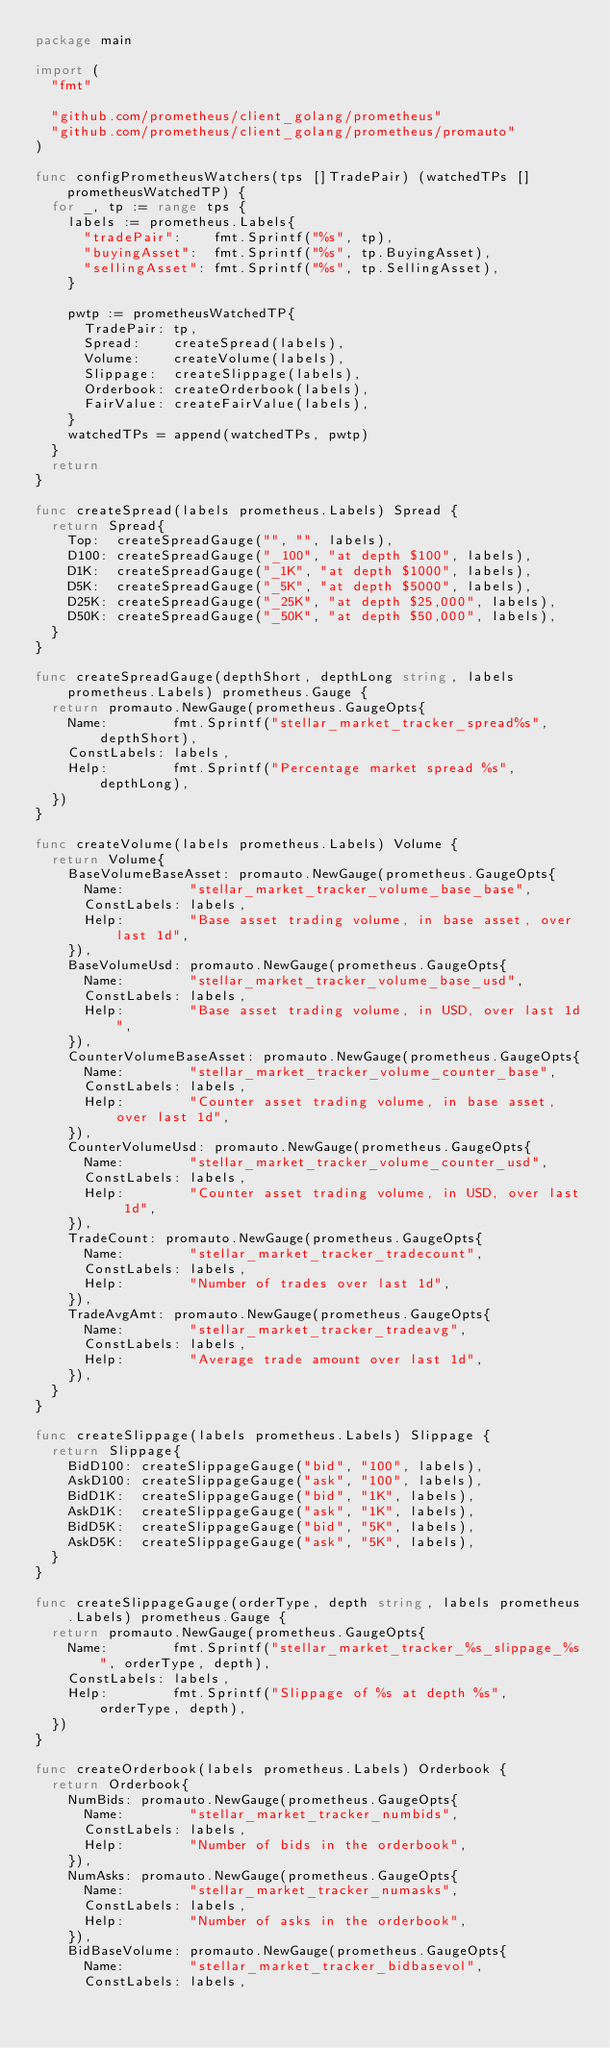<code> <loc_0><loc_0><loc_500><loc_500><_Go_>package main

import (
	"fmt"

	"github.com/prometheus/client_golang/prometheus"
	"github.com/prometheus/client_golang/prometheus/promauto"
)

func configPrometheusWatchers(tps []TradePair) (watchedTPs []prometheusWatchedTP) {
	for _, tp := range tps {
		labels := prometheus.Labels{
			"tradePair":    fmt.Sprintf("%s", tp),
			"buyingAsset":  fmt.Sprintf("%s", tp.BuyingAsset),
			"sellingAsset": fmt.Sprintf("%s", tp.SellingAsset),
		}

		pwtp := prometheusWatchedTP{
			TradePair: tp,
			Spread:    createSpread(labels),
			Volume:    createVolume(labels),
			Slippage:  createSlippage(labels),
			Orderbook: createOrderbook(labels),
			FairValue: createFairValue(labels),
		}
		watchedTPs = append(watchedTPs, pwtp)
	}
	return
}

func createSpread(labels prometheus.Labels) Spread {
	return Spread{
		Top:  createSpreadGauge("", "", labels),
		D100: createSpreadGauge("_100", "at depth $100", labels),
		D1K:  createSpreadGauge("_1K", "at depth $1000", labels),
		D5K:  createSpreadGauge("_5K", "at depth $5000", labels),
		D25K: createSpreadGauge("_25K", "at depth $25,000", labels),
		D50K: createSpreadGauge("_50K", "at depth $50,000", labels),
	}
}

func createSpreadGauge(depthShort, depthLong string, labels prometheus.Labels) prometheus.Gauge {
	return promauto.NewGauge(prometheus.GaugeOpts{
		Name:        fmt.Sprintf("stellar_market_tracker_spread%s", depthShort),
		ConstLabels: labels,
		Help:        fmt.Sprintf("Percentage market spread %s", depthLong),
	})
}

func createVolume(labels prometheus.Labels) Volume {
	return Volume{
		BaseVolumeBaseAsset: promauto.NewGauge(prometheus.GaugeOpts{
			Name:        "stellar_market_tracker_volume_base_base",
			ConstLabels: labels,
			Help:        "Base asset trading volume, in base asset, over last 1d",
		}),
		BaseVolumeUsd: promauto.NewGauge(prometheus.GaugeOpts{
			Name:        "stellar_market_tracker_volume_base_usd",
			ConstLabels: labels,
			Help:        "Base asset trading volume, in USD, over last 1d",
		}),
		CounterVolumeBaseAsset: promauto.NewGauge(prometheus.GaugeOpts{
			Name:        "stellar_market_tracker_volume_counter_base",
			ConstLabels: labels,
			Help:        "Counter asset trading volume, in base asset, over last 1d",
		}),
		CounterVolumeUsd: promauto.NewGauge(prometheus.GaugeOpts{
			Name:        "stellar_market_tracker_volume_counter_usd",
			ConstLabels: labels,
			Help:        "Counter asset trading volume, in USD, over last 1d",
		}),
		TradeCount: promauto.NewGauge(prometheus.GaugeOpts{
			Name:        "stellar_market_tracker_tradecount",
			ConstLabels: labels,
			Help:        "Number of trades over last 1d",
		}),
		TradeAvgAmt: promauto.NewGauge(prometheus.GaugeOpts{
			Name:        "stellar_market_tracker_tradeavg",
			ConstLabels: labels,
			Help:        "Average trade amount over last 1d",
		}),
	}
}

func createSlippage(labels prometheus.Labels) Slippage {
	return Slippage{
		BidD100: createSlippageGauge("bid", "100", labels),
		AskD100: createSlippageGauge("ask", "100", labels),
		BidD1K:  createSlippageGauge("bid", "1K", labels),
		AskD1K:  createSlippageGauge("ask", "1K", labels),
		BidD5K:  createSlippageGauge("bid", "5K", labels),
		AskD5K:  createSlippageGauge("ask", "5K", labels),
	}
}

func createSlippageGauge(orderType, depth string, labels prometheus.Labels) prometheus.Gauge {
	return promauto.NewGauge(prometheus.GaugeOpts{
		Name:        fmt.Sprintf("stellar_market_tracker_%s_slippage_%s", orderType, depth),
		ConstLabels: labels,
		Help:        fmt.Sprintf("Slippage of %s at depth %s", orderType, depth),
	})
}

func createOrderbook(labels prometheus.Labels) Orderbook {
	return Orderbook{
		NumBids: promauto.NewGauge(prometheus.GaugeOpts{
			Name:        "stellar_market_tracker_numbids",
			ConstLabels: labels,
			Help:        "Number of bids in the orderbook",
		}),
		NumAsks: promauto.NewGauge(prometheus.GaugeOpts{
			Name:        "stellar_market_tracker_numasks",
			ConstLabels: labels,
			Help:        "Number of asks in the orderbook",
		}),
		BidBaseVolume: promauto.NewGauge(prometheus.GaugeOpts{
			Name:        "stellar_market_tracker_bidbasevol",
			ConstLabels: labels,</code> 